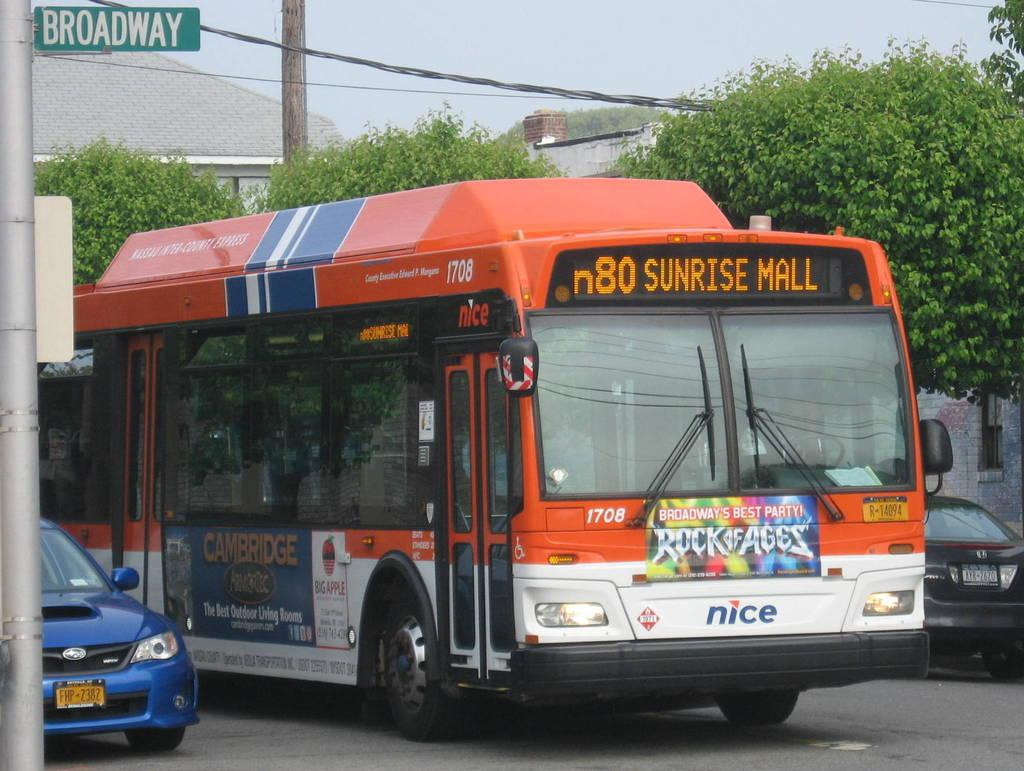What types of objects can be seen in the image? There are vehicles and a board in the image. What natural elements are present in the image? There are trees in the image. What man-made structure can be seen in the image? There is a pole in the image. What can be seen in the background of the image? The sky is visible in the background of the image. What type of pancake is being used to write on the board in the image? There is no pancake present in the image, and the board does not show any writing. What cast member from a popular TV show can be seen in the image? There are no people or cast members present in the image. 